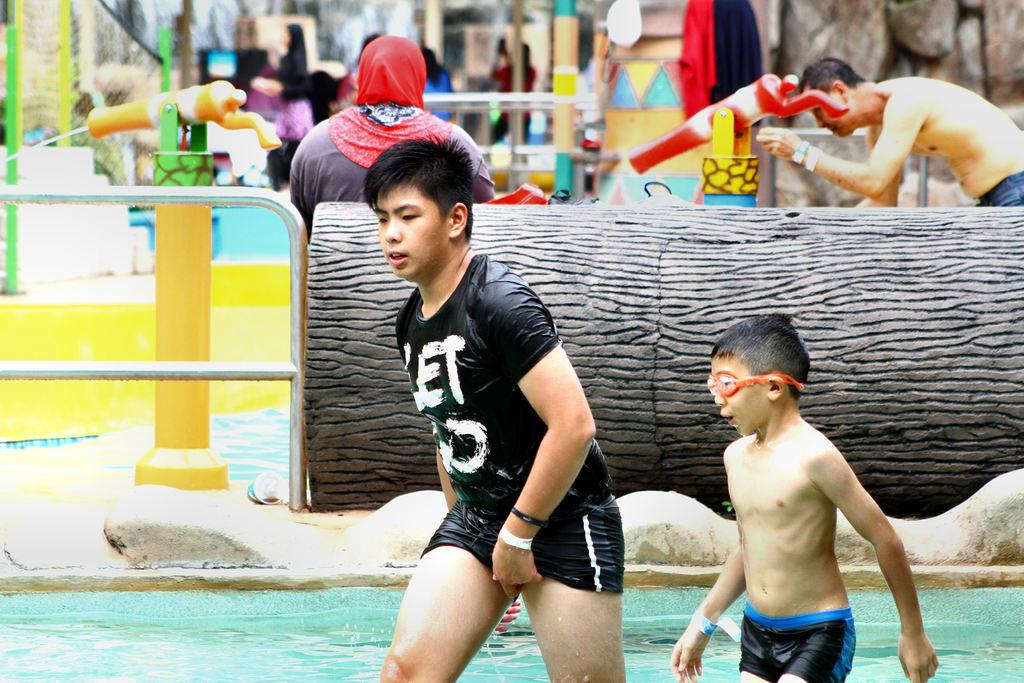Who or what can be seen in the image? There are people in the image. What is visible in the image besides the people? There is water, rods, poles, clothes, and other objects visible in the image. Can you describe the setting of the image? The background of the image is blurry, but there are people, objects, and water visible. What might be the purpose of the rods and poles in the image? The rods and poles might be used for hanging or drying clothes, as clothes are present in the image. Are there any other people or objects in the background of the image? Yes, there are people and objects in the background of the image. What type of flight can be seen taking off in the image? There is no flight visible in the image; it features people, water, rods, poles, clothes, and objects. What kind of waste is being disposed of in the image? There is no waste disposal visible in the image; it focuses on people, water, rods, poles, clothes, and objects. 